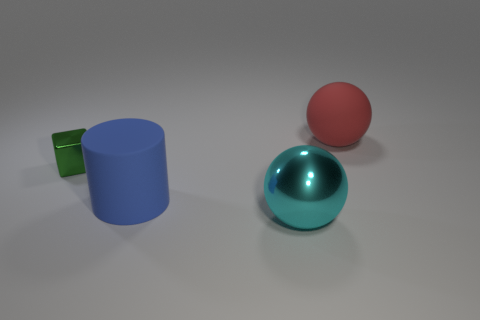There is a object that is right of the cyan metal ball; what size is it?
Offer a very short reply. Large. Are there an equal number of large shiny things that are behind the big blue rubber thing and small shiny things?
Give a very brief answer. No. Is there a blue matte thing of the same shape as the green object?
Offer a very short reply. No. There is a object that is both behind the large blue cylinder and on the left side of the big red ball; what is its shape?
Your answer should be very brief. Cube. Is the material of the cyan sphere the same as the tiny block that is to the left of the large blue matte cylinder?
Provide a short and direct response. Yes. Are there any large red balls to the left of the large red ball?
Offer a very short reply. No. How many things are either red rubber spheres or things that are in front of the green thing?
Offer a terse response. 3. There is a big object right of the metal object in front of the small green object; what is its color?
Offer a terse response. Red. What number of other things are made of the same material as the blue cylinder?
Provide a succinct answer. 1. What number of shiny things are green things or small cyan things?
Give a very brief answer. 1. 